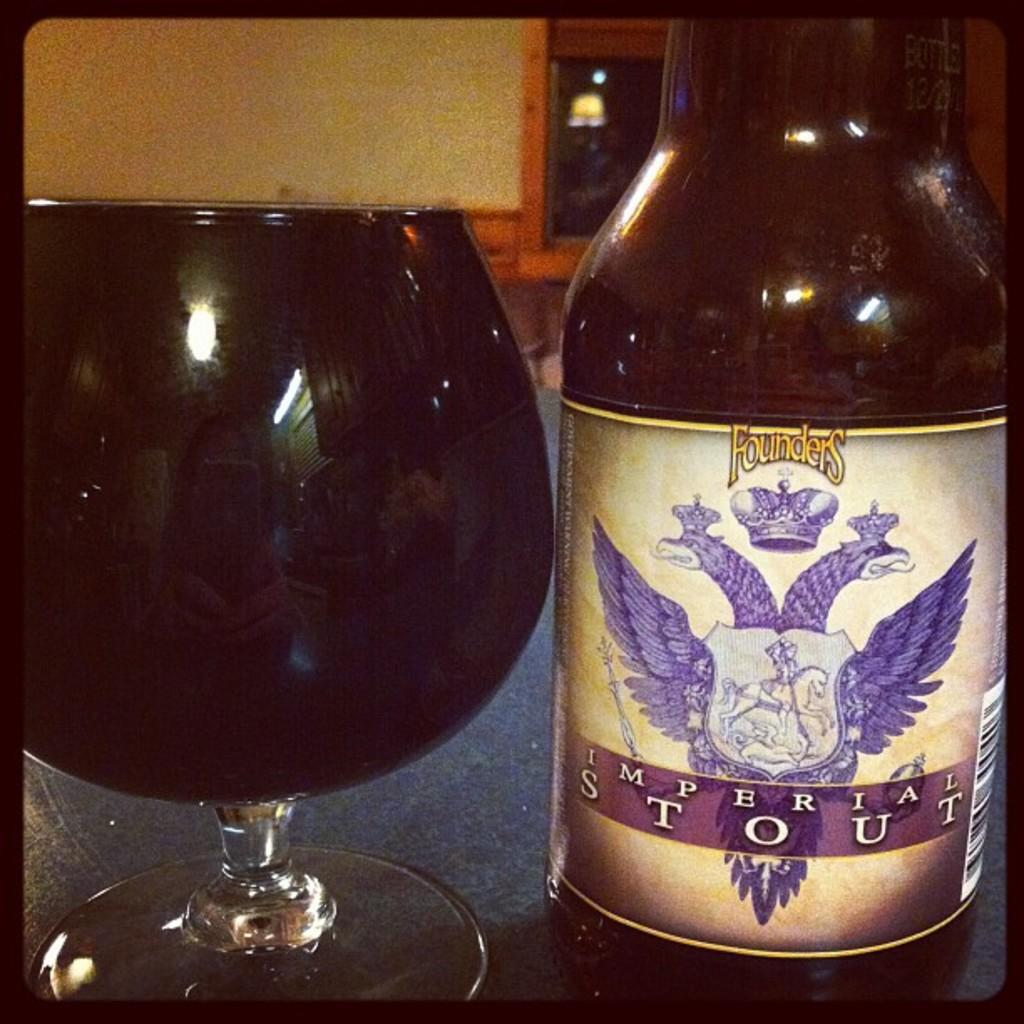<image>
Describe the image concisely. Bottle of Founders Imperial Stout beer next to a full glass of beer. 